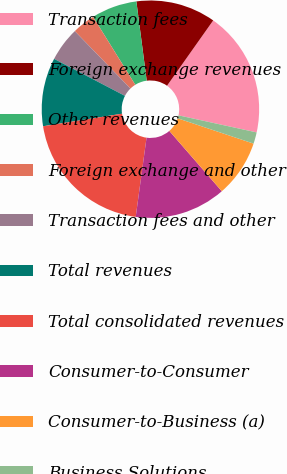Convert chart. <chart><loc_0><loc_0><loc_500><loc_500><pie_chart><fcel>Transaction fees<fcel>Foreign exchange revenues<fcel>Other revenues<fcel>Foreign exchange and other<fcel>Transaction fees and other<fcel>Total revenues<fcel>Total consolidated revenues<fcel>Consumer-to-Consumer<fcel>Consumer-to-Business (a)<fcel>Business Solutions<nl><fcel>18.63%<fcel>11.86%<fcel>6.78%<fcel>3.4%<fcel>5.09%<fcel>10.17%<fcel>20.33%<fcel>13.56%<fcel>8.48%<fcel>1.7%<nl></chart> 